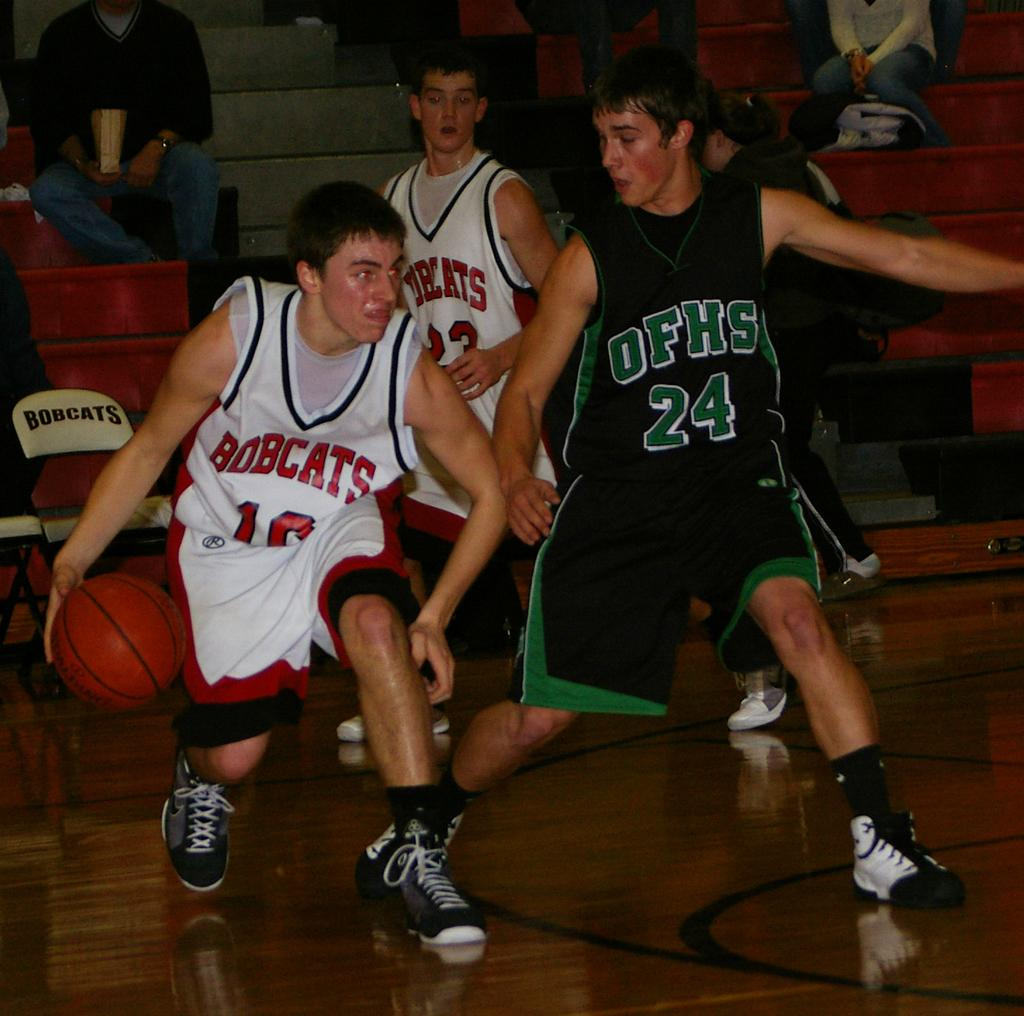<image>
Write a terse but informative summary of the picture. some basketball players, one wearing the number 24 